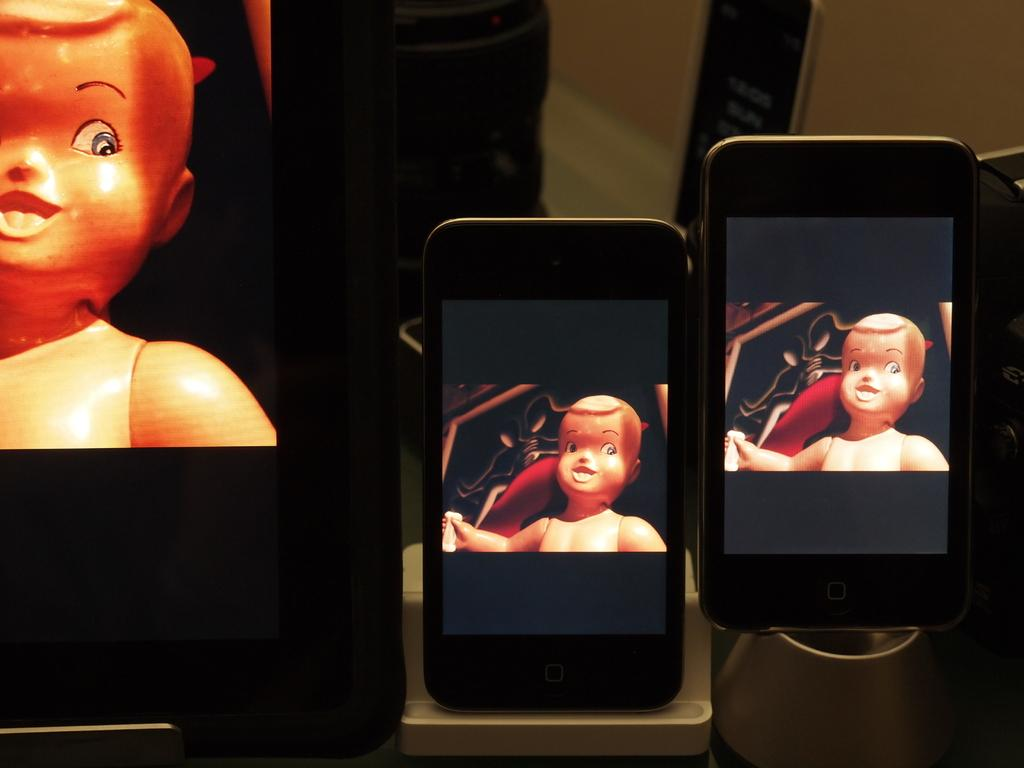What is the main subject of the image? The main subject of the image is many phones. What can be seen on the displays of the phones? On the displays of the phones, there is a picture of a toy kid. What type of marble is being used to play a game on the railway in the image? There is no marble or railway present in the image; it features phones with a picture of a toy kid on their displays. 